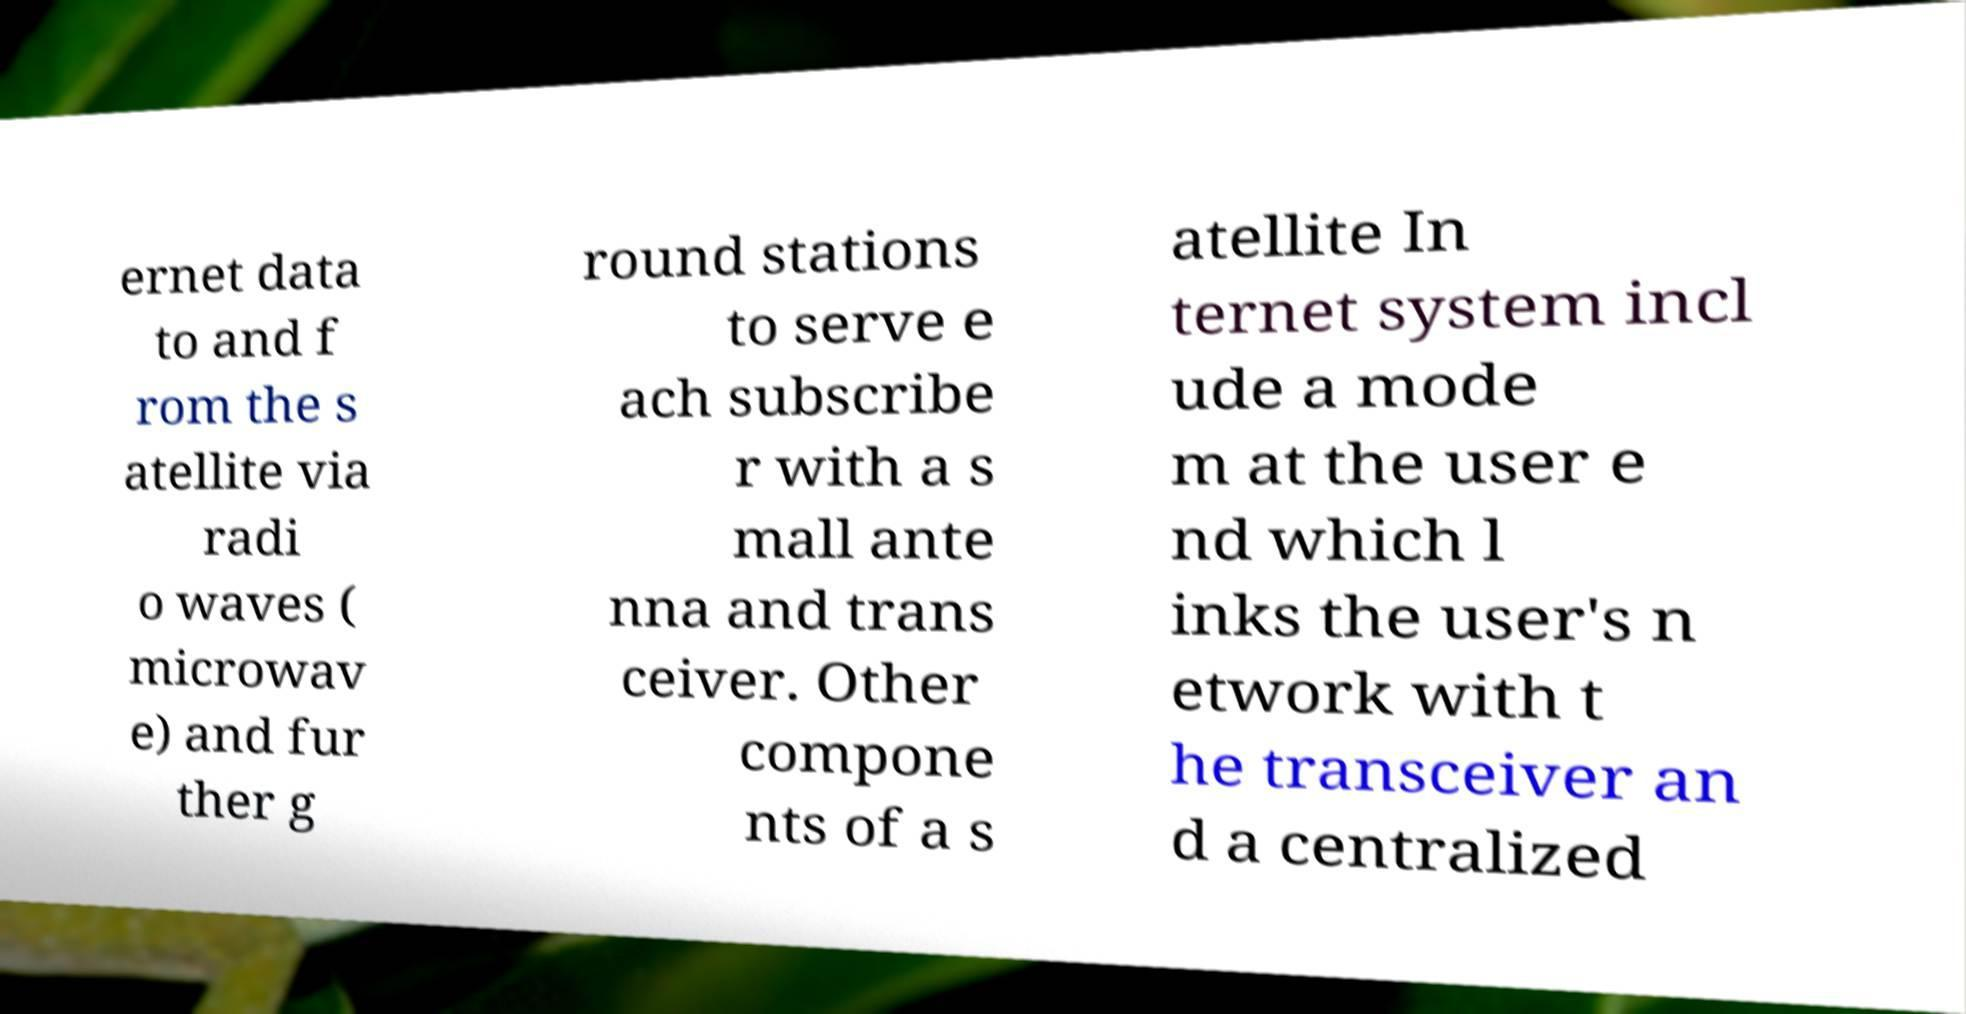Can you accurately transcribe the text from the provided image for me? ernet data to and f rom the s atellite via radi o waves ( microwav e) and fur ther g round stations to serve e ach subscribe r with a s mall ante nna and trans ceiver. Other compone nts of a s atellite In ternet system incl ude a mode m at the user e nd which l inks the user's n etwork with t he transceiver an d a centralized 